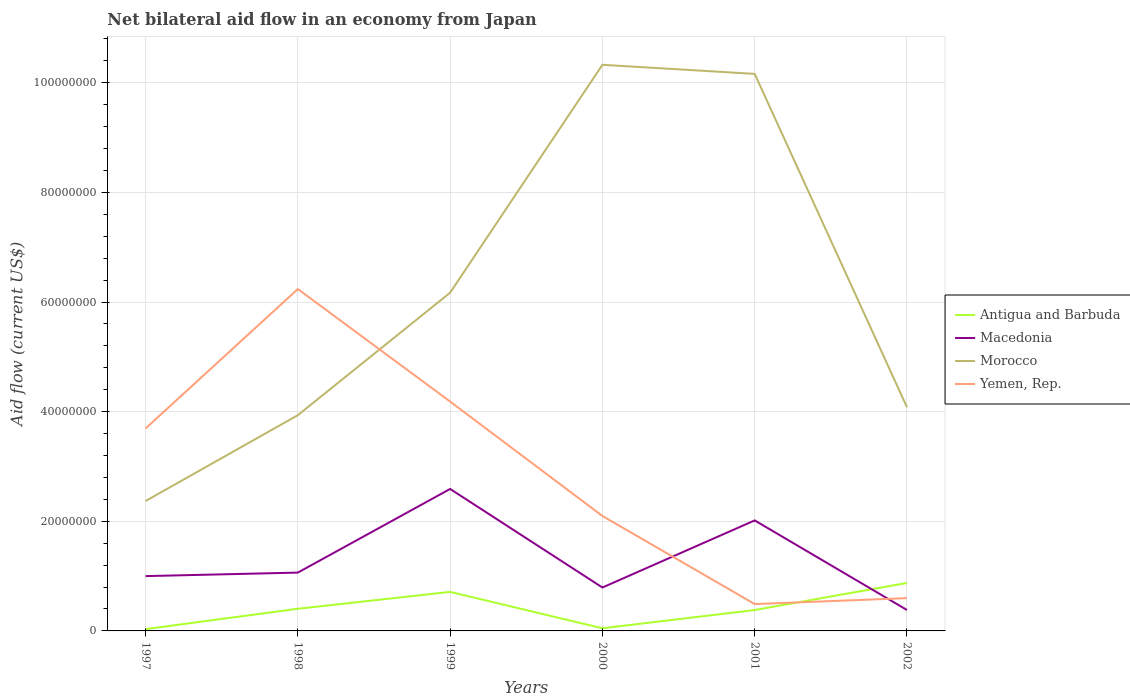Across all years, what is the maximum net bilateral aid flow in Antigua and Barbuda?
Offer a terse response. 3.30e+05. In which year was the net bilateral aid flow in Macedonia maximum?
Your answer should be very brief. 2002. What is the total net bilateral aid flow in Antigua and Barbuda in the graph?
Offer a terse response. -4.94e+06. What is the difference between the highest and the second highest net bilateral aid flow in Macedonia?
Your answer should be very brief. 2.21e+07. What is the difference between the highest and the lowest net bilateral aid flow in Yemen, Rep.?
Give a very brief answer. 3. Is the net bilateral aid flow in Macedonia strictly greater than the net bilateral aid flow in Antigua and Barbuda over the years?
Your answer should be very brief. No. How many lines are there?
Your response must be concise. 4. What is the difference between two consecutive major ticks on the Y-axis?
Offer a very short reply. 2.00e+07. Are the values on the major ticks of Y-axis written in scientific E-notation?
Offer a terse response. No. Does the graph contain grids?
Give a very brief answer. Yes. What is the title of the graph?
Your response must be concise. Net bilateral aid flow in an economy from Japan. What is the label or title of the Y-axis?
Offer a very short reply. Aid flow (current US$). What is the Aid flow (current US$) in Antigua and Barbuda in 1997?
Provide a succinct answer. 3.30e+05. What is the Aid flow (current US$) of Macedonia in 1997?
Keep it short and to the point. 1.00e+07. What is the Aid flow (current US$) in Morocco in 1997?
Make the answer very short. 2.37e+07. What is the Aid flow (current US$) in Yemen, Rep. in 1997?
Offer a very short reply. 3.69e+07. What is the Aid flow (current US$) of Antigua and Barbuda in 1998?
Provide a short and direct response. 4.04e+06. What is the Aid flow (current US$) in Macedonia in 1998?
Keep it short and to the point. 1.06e+07. What is the Aid flow (current US$) in Morocco in 1998?
Offer a very short reply. 3.94e+07. What is the Aid flow (current US$) in Yemen, Rep. in 1998?
Offer a very short reply. 6.24e+07. What is the Aid flow (current US$) of Antigua and Barbuda in 1999?
Provide a short and direct response. 7.12e+06. What is the Aid flow (current US$) of Macedonia in 1999?
Your response must be concise. 2.59e+07. What is the Aid flow (current US$) of Morocco in 1999?
Offer a very short reply. 6.17e+07. What is the Aid flow (current US$) of Yemen, Rep. in 1999?
Make the answer very short. 4.18e+07. What is the Aid flow (current US$) in Macedonia in 2000?
Make the answer very short. 7.92e+06. What is the Aid flow (current US$) of Morocco in 2000?
Make the answer very short. 1.03e+08. What is the Aid flow (current US$) of Yemen, Rep. in 2000?
Offer a terse response. 2.10e+07. What is the Aid flow (current US$) of Antigua and Barbuda in 2001?
Give a very brief answer. 3.81e+06. What is the Aid flow (current US$) of Macedonia in 2001?
Ensure brevity in your answer.  2.02e+07. What is the Aid flow (current US$) of Morocco in 2001?
Keep it short and to the point. 1.02e+08. What is the Aid flow (current US$) of Yemen, Rep. in 2001?
Ensure brevity in your answer.  4.90e+06. What is the Aid flow (current US$) of Antigua and Barbuda in 2002?
Make the answer very short. 8.75e+06. What is the Aid flow (current US$) in Macedonia in 2002?
Provide a short and direct response. 3.82e+06. What is the Aid flow (current US$) in Morocco in 2002?
Provide a succinct answer. 4.08e+07. What is the Aid flow (current US$) of Yemen, Rep. in 2002?
Offer a very short reply. 5.98e+06. Across all years, what is the maximum Aid flow (current US$) in Antigua and Barbuda?
Your answer should be compact. 8.75e+06. Across all years, what is the maximum Aid flow (current US$) in Macedonia?
Give a very brief answer. 2.59e+07. Across all years, what is the maximum Aid flow (current US$) in Morocco?
Keep it short and to the point. 1.03e+08. Across all years, what is the maximum Aid flow (current US$) of Yemen, Rep.?
Your answer should be compact. 6.24e+07. Across all years, what is the minimum Aid flow (current US$) in Antigua and Barbuda?
Your response must be concise. 3.30e+05. Across all years, what is the minimum Aid flow (current US$) in Macedonia?
Provide a succinct answer. 3.82e+06. Across all years, what is the minimum Aid flow (current US$) of Morocco?
Keep it short and to the point. 2.37e+07. Across all years, what is the minimum Aid flow (current US$) in Yemen, Rep.?
Keep it short and to the point. 4.90e+06. What is the total Aid flow (current US$) of Antigua and Barbuda in the graph?
Ensure brevity in your answer.  2.45e+07. What is the total Aid flow (current US$) of Macedonia in the graph?
Keep it short and to the point. 7.84e+07. What is the total Aid flow (current US$) in Morocco in the graph?
Your answer should be compact. 3.70e+08. What is the total Aid flow (current US$) in Yemen, Rep. in the graph?
Provide a succinct answer. 1.73e+08. What is the difference between the Aid flow (current US$) in Antigua and Barbuda in 1997 and that in 1998?
Your answer should be compact. -3.71e+06. What is the difference between the Aid flow (current US$) in Macedonia in 1997 and that in 1998?
Your answer should be compact. -6.40e+05. What is the difference between the Aid flow (current US$) of Morocco in 1997 and that in 1998?
Your answer should be very brief. -1.57e+07. What is the difference between the Aid flow (current US$) in Yemen, Rep. in 1997 and that in 1998?
Keep it short and to the point. -2.54e+07. What is the difference between the Aid flow (current US$) of Antigua and Barbuda in 1997 and that in 1999?
Provide a succinct answer. -6.79e+06. What is the difference between the Aid flow (current US$) of Macedonia in 1997 and that in 1999?
Give a very brief answer. -1.59e+07. What is the difference between the Aid flow (current US$) in Morocco in 1997 and that in 1999?
Offer a very short reply. -3.80e+07. What is the difference between the Aid flow (current US$) in Yemen, Rep. in 1997 and that in 1999?
Make the answer very short. -4.91e+06. What is the difference between the Aid flow (current US$) in Macedonia in 1997 and that in 2000?
Your answer should be compact. 2.08e+06. What is the difference between the Aid flow (current US$) of Morocco in 1997 and that in 2000?
Make the answer very short. -7.96e+07. What is the difference between the Aid flow (current US$) in Yemen, Rep. in 1997 and that in 2000?
Provide a succinct answer. 1.60e+07. What is the difference between the Aid flow (current US$) of Antigua and Barbuda in 1997 and that in 2001?
Ensure brevity in your answer.  -3.48e+06. What is the difference between the Aid flow (current US$) of Macedonia in 1997 and that in 2001?
Your answer should be very brief. -1.02e+07. What is the difference between the Aid flow (current US$) of Morocco in 1997 and that in 2001?
Your answer should be compact. -7.79e+07. What is the difference between the Aid flow (current US$) in Yemen, Rep. in 1997 and that in 2001?
Give a very brief answer. 3.20e+07. What is the difference between the Aid flow (current US$) of Antigua and Barbuda in 1997 and that in 2002?
Ensure brevity in your answer.  -8.42e+06. What is the difference between the Aid flow (current US$) in Macedonia in 1997 and that in 2002?
Offer a very short reply. 6.18e+06. What is the difference between the Aid flow (current US$) in Morocco in 1997 and that in 2002?
Offer a very short reply. -1.71e+07. What is the difference between the Aid flow (current US$) of Yemen, Rep. in 1997 and that in 2002?
Ensure brevity in your answer.  3.10e+07. What is the difference between the Aid flow (current US$) in Antigua and Barbuda in 1998 and that in 1999?
Your answer should be compact. -3.08e+06. What is the difference between the Aid flow (current US$) of Macedonia in 1998 and that in 1999?
Give a very brief answer. -1.53e+07. What is the difference between the Aid flow (current US$) of Morocco in 1998 and that in 1999?
Give a very brief answer. -2.24e+07. What is the difference between the Aid flow (current US$) in Yemen, Rep. in 1998 and that in 1999?
Offer a very short reply. 2.05e+07. What is the difference between the Aid flow (current US$) in Antigua and Barbuda in 1998 and that in 2000?
Provide a short and direct response. 3.56e+06. What is the difference between the Aid flow (current US$) of Macedonia in 1998 and that in 2000?
Your answer should be compact. 2.72e+06. What is the difference between the Aid flow (current US$) in Morocco in 1998 and that in 2000?
Your answer should be very brief. -6.39e+07. What is the difference between the Aid flow (current US$) in Yemen, Rep. in 1998 and that in 2000?
Your answer should be very brief. 4.14e+07. What is the difference between the Aid flow (current US$) of Antigua and Barbuda in 1998 and that in 2001?
Provide a succinct answer. 2.30e+05. What is the difference between the Aid flow (current US$) in Macedonia in 1998 and that in 2001?
Keep it short and to the point. -9.52e+06. What is the difference between the Aid flow (current US$) of Morocco in 1998 and that in 2001?
Provide a short and direct response. -6.23e+07. What is the difference between the Aid flow (current US$) in Yemen, Rep. in 1998 and that in 2001?
Your response must be concise. 5.75e+07. What is the difference between the Aid flow (current US$) of Antigua and Barbuda in 1998 and that in 2002?
Offer a terse response. -4.71e+06. What is the difference between the Aid flow (current US$) of Macedonia in 1998 and that in 2002?
Your answer should be very brief. 6.82e+06. What is the difference between the Aid flow (current US$) of Morocco in 1998 and that in 2002?
Give a very brief answer. -1.44e+06. What is the difference between the Aid flow (current US$) of Yemen, Rep. in 1998 and that in 2002?
Give a very brief answer. 5.64e+07. What is the difference between the Aid flow (current US$) of Antigua and Barbuda in 1999 and that in 2000?
Your response must be concise. 6.64e+06. What is the difference between the Aid flow (current US$) in Macedonia in 1999 and that in 2000?
Give a very brief answer. 1.80e+07. What is the difference between the Aid flow (current US$) in Morocco in 1999 and that in 2000?
Offer a very short reply. -4.16e+07. What is the difference between the Aid flow (current US$) in Yemen, Rep. in 1999 and that in 2000?
Your response must be concise. 2.09e+07. What is the difference between the Aid flow (current US$) of Antigua and Barbuda in 1999 and that in 2001?
Your answer should be very brief. 3.31e+06. What is the difference between the Aid flow (current US$) of Macedonia in 1999 and that in 2001?
Make the answer very short. 5.74e+06. What is the difference between the Aid flow (current US$) in Morocco in 1999 and that in 2001?
Make the answer very short. -3.99e+07. What is the difference between the Aid flow (current US$) in Yemen, Rep. in 1999 and that in 2001?
Your answer should be compact. 3.69e+07. What is the difference between the Aid flow (current US$) of Antigua and Barbuda in 1999 and that in 2002?
Your answer should be compact. -1.63e+06. What is the difference between the Aid flow (current US$) in Macedonia in 1999 and that in 2002?
Provide a succinct answer. 2.21e+07. What is the difference between the Aid flow (current US$) of Morocco in 1999 and that in 2002?
Keep it short and to the point. 2.09e+07. What is the difference between the Aid flow (current US$) in Yemen, Rep. in 1999 and that in 2002?
Make the answer very short. 3.59e+07. What is the difference between the Aid flow (current US$) in Antigua and Barbuda in 2000 and that in 2001?
Keep it short and to the point. -3.33e+06. What is the difference between the Aid flow (current US$) in Macedonia in 2000 and that in 2001?
Offer a very short reply. -1.22e+07. What is the difference between the Aid flow (current US$) of Morocco in 2000 and that in 2001?
Offer a very short reply. 1.66e+06. What is the difference between the Aid flow (current US$) of Yemen, Rep. in 2000 and that in 2001?
Offer a terse response. 1.61e+07. What is the difference between the Aid flow (current US$) of Antigua and Barbuda in 2000 and that in 2002?
Give a very brief answer. -8.27e+06. What is the difference between the Aid flow (current US$) of Macedonia in 2000 and that in 2002?
Your answer should be very brief. 4.10e+06. What is the difference between the Aid flow (current US$) of Morocco in 2000 and that in 2002?
Offer a very short reply. 6.25e+07. What is the difference between the Aid flow (current US$) of Yemen, Rep. in 2000 and that in 2002?
Keep it short and to the point. 1.50e+07. What is the difference between the Aid flow (current US$) in Antigua and Barbuda in 2001 and that in 2002?
Offer a terse response. -4.94e+06. What is the difference between the Aid flow (current US$) in Macedonia in 2001 and that in 2002?
Give a very brief answer. 1.63e+07. What is the difference between the Aid flow (current US$) of Morocco in 2001 and that in 2002?
Give a very brief answer. 6.08e+07. What is the difference between the Aid flow (current US$) in Yemen, Rep. in 2001 and that in 2002?
Offer a very short reply. -1.08e+06. What is the difference between the Aid flow (current US$) in Antigua and Barbuda in 1997 and the Aid flow (current US$) in Macedonia in 1998?
Offer a terse response. -1.03e+07. What is the difference between the Aid flow (current US$) in Antigua and Barbuda in 1997 and the Aid flow (current US$) in Morocco in 1998?
Give a very brief answer. -3.90e+07. What is the difference between the Aid flow (current US$) in Antigua and Barbuda in 1997 and the Aid flow (current US$) in Yemen, Rep. in 1998?
Make the answer very short. -6.20e+07. What is the difference between the Aid flow (current US$) of Macedonia in 1997 and the Aid flow (current US$) of Morocco in 1998?
Offer a very short reply. -2.94e+07. What is the difference between the Aid flow (current US$) in Macedonia in 1997 and the Aid flow (current US$) in Yemen, Rep. in 1998?
Make the answer very short. -5.24e+07. What is the difference between the Aid flow (current US$) in Morocco in 1997 and the Aid flow (current US$) in Yemen, Rep. in 1998?
Keep it short and to the point. -3.87e+07. What is the difference between the Aid flow (current US$) of Antigua and Barbuda in 1997 and the Aid flow (current US$) of Macedonia in 1999?
Offer a very short reply. -2.56e+07. What is the difference between the Aid flow (current US$) in Antigua and Barbuda in 1997 and the Aid flow (current US$) in Morocco in 1999?
Give a very brief answer. -6.14e+07. What is the difference between the Aid flow (current US$) of Antigua and Barbuda in 1997 and the Aid flow (current US$) of Yemen, Rep. in 1999?
Give a very brief answer. -4.15e+07. What is the difference between the Aid flow (current US$) of Macedonia in 1997 and the Aid flow (current US$) of Morocco in 1999?
Provide a succinct answer. -5.17e+07. What is the difference between the Aid flow (current US$) of Macedonia in 1997 and the Aid flow (current US$) of Yemen, Rep. in 1999?
Your response must be concise. -3.18e+07. What is the difference between the Aid flow (current US$) of Morocco in 1997 and the Aid flow (current US$) of Yemen, Rep. in 1999?
Ensure brevity in your answer.  -1.81e+07. What is the difference between the Aid flow (current US$) in Antigua and Barbuda in 1997 and the Aid flow (current US$) in Macedonia in 2000?
Give a very brief answer. -7.59e+06. What is the difference between the Aid flow (current US$) in Antigua and Barbuda in 1997 and the Aid flow (current US$) in Morocco in 2000?
Provide a succinct answer. -1.03e+08. What is the difference between the Aid flow (current US$) in Antigua and Barbuda in 1997 and the Aid flow (current US$) in Yemen, Rep. in 2000?
Your response must be concise. -2.06e+07. What is the difference between the Aid flow (current US$) of Macedonia in 1997 and the Aid flow (current US$) of Morocco in 2000?
Offer a terse response. -9.33e+07. What is the difference between the Aid flow (current US$) of Macedonia in 1997 and the Aid flow (current US$) of Yemen, Rep. in 2000?
Make the answer very short. -1.10e+07. What is the difference between the Aid flow (current US$) of Morocco in 1997 and the Aid flow (current US$) of Yemen, Rep. in 2000?
Offer a terse response. 2.73e+06. What is the difference between the Aid flow (current US$) of Antigua and Barbuda in 1997 and the Aid flow (current US$) of Macedonia in 2001?
Provide a short and direct response. -1.98e+07. What is the difference between the Aid flow (current US$) of Antigua and Barbuda in 1997 and the Aid flow (current US$) of Morocco in 2001?
Give a very brief answer. -1.01e+08. What is the difference between the Aid flow (current US$) of Antigua and Barbuda in 1997 and the Aid flow (current US$) of Yemen, Rep. in 2001?
Your response must be concise. -4.57e+06. What is the difference between the Aid flow (current US$) in Macedonia in 1997 and the Aid flow (current US$) in Morocco in 2001?
Offer a very short reply. -9.16e+07. What is the difference between the Aid flow (current US$) in Macedonia in 1997 and the Aid flow (current US$) in Yemen, Rep. in 2001?
Give a very brief answer. 5.10e+06. What is the difference between the Aid flow (current US$) of Morocco in 1997 and the Aid flow (current US$) of Yemen, Rep. in 2001?
Your answer should be very brief. 1.88e+07. What is the difference between the Aid flow (current US$) in Antigua and Barbuda in 1997 and the Aid flow (current US$) in Macedonia in 2002?
Ensure brevity in your answer.  -3.49e+06. What is the difference between the Aid flow (current US$) of Antigua and Barbuda in 1997 and the Aid flow (current US$) of Morocco in 2002?
Your response must be concise. -4.05e+07. What is the difference between the Aid flow (current US$) of Antigua and Barbuda in 1997 and the Aid flow (current US$) of Yemen, Rep. in 2002?
Make the answer very short. -5.65e+06. What is the difference between the Aid flow (current US$) of Macedonia in 1997 and the Aid flow (current US$) of Morocco in 2002?
Ensure brevity in your answer.  -3.08e+07. What is the difference between the Aid flow (current US$) of Macedonia in 1997 and the Aid flow (current US$) of Yemen, Rep. in 2002?
Your answer should be very brief. 4.02e+06. What is the difference between the Aid flow (current US$) in Morocco in 1997 and the Aid flow (current US$) in Yemen, Rep. in 2002?
Ensure brevity in your answer.  1.77e+07. What is the difference between the Aid flow (current US$) in Antigua and Barbuda in 1998 and the Aid flow (current US$) in Macedonia in 1999?
Your answer should be very brief. -2.19e+07. What is the difference between the Aid flow (current US$) of Antigua and Barbuda in 1998 and the Aid flow (current US$) of Morocco in 1999?
Offer a very short reply. -5.77e+07. What is the difference between the Aid flow (current US$) of Antigua and Barbuda in 1998 and the Aid flow (current US$) of Yemen, Rep. in 1999?
Your answer should be very brief. -3.78e+07. What is the difference between the Aid flow (current US$) in Macedonia in 1998 and the Aid flow (current US$) in Morocco in 1999?
Give a very brief answer. -5.11e+07. What is the difference between the Aid flow (current US$) in Macedonia in 1998 and the Aid flow (current US$) in Yemen, Rep. in 1999?
Offer a terse response. -3.12e+07. What is the difference between the Aid flow (current US$) of Morocco in 1998 and the Aid flow (current US$) of Yemen, Rep. in 1999?
Keep it short and to the point. -2.48e+06. What is the difference between the Aid flow (current US$) in Antigua and Barbuda in 1998 and the Aid flow (current US$) in Macedonia in 2000?
Offer a very short reply. -3.88e+06. What is the difference between the Aid flow (current US$) of Antigua and Barbuda in 1998 and the Aid flow (current US$) of Morocco in 2000?
Your response must be concise. -9.92e+07. What is the difference between the Aid flow (current US$) of Antigua and Barbuda in 1998 and the Aid flow (current US$) of Yemen, Rep. in 2000?
Your answer should be compact. -1.69e+07. What is the difference between the Aid flow (current US$) in Macedonia in 1998 and the Aid flow (current US$) in Morocco in 2000?
Ensure brevity in your answer.  -9.26e+07. What is the difference between the Aid flow (current US$) in Macedonia in 1998 and the Aid flow (current US$) in Yemen, Rep. in 2000?
Provide a short and direct response. -1.03e+07. What is the difference between the Aid flow (current US$) of Morocco in 1998 and the Aid flow (current US$) of Yemen, Rep. in 2000?
Ensure brevity in your answer.  1.84e+07. What is the difference between the Aid flow (current US$) of Antigua and Barbuda in 1998 and the Aid flow (current US$) of Macedonia in 2001?
Offer a very short reply. -1.61e+07. What is the difference between the Aid flow (current US$) of Antigua and Barbuda in 1998 and the Aid flow (current US$) of Morocco in 2001?
Give a very brief answer. -9.76e+07. What is the difference between the Aid flow (current US$) of Antigua and Barbuda in 1998 and the Aid flow (current US$) of Yemen, Rep. in 2001?
Make the answer very short. -8.60e+05. What is the difference between the Aid flow (current US$) of Macedonia in 1998 and the Aid flow (current US$) of Morocco in 2001?
Ensure brevity in your answer.  -9.10e+07. What is the difference between the Aid flow (current US$) in Macedonia in 1998 and the Aid flow (current US$) in Yemen, Rep. in 2001?
Provide a succinct answer. 5.74e+06. What is the difference between the Aid flow (current US$) in Morocco in 1998 and the Aid flow (current US$) in Yemen, Rep. in 2001?
Offer a very short reply. 3.45e+07. What is the difference between the Aid flow (current US$) of Antigua and Barbuda in 1998 and the Aid flow (current US$) of Macedonia in 2002?
Make the answer very short. 2.20e+05. What is the difference between the Aid flow (current US$) of Antigua and Barbuda in 1998 and the Aid flow (current US$) of Morocco in 2002?
Give a very brief answer. -3.68e+07. What is the difference between the Aid flow (current US$) in Antigua and Barbuda in 1998 and the Aid flow (current US$) in Yemen, Rep. in 2002?
Your answer should be compact. -1.94e+06. What is the difference between the Aid flow (current US$) in Macedonia in 1998 and the Aid flow (current US$) in Morocco in 2002?
Your response must be concise. -3.02e+07. What is the difference between the Aid flow (current US$) in Macedonia in 1998 and the Aid flow (current US$) in Yemen, Rep. in 2002?
Keep it short and to the point. 4.66e+06. What is the difference between the Aid flow (current US$) in Morocco in 1998 and the Aid flow (current US$) in Yemen, Rep. in 2002?
Your answer should be compact. 3.34e+07. What is the difference between the Aid flow (current US$) of Antigua and Barbuda in 1999 and the Aid flow (current US$) of Macedonia in 2000?
Provide a short and direct response. -8.00e+05. What is the difference between the Aid flow (current US$) in Antigua and Barbuda in 1999 and the Aid flow (current US$) in Morocco in 2000?
Keep it short and to the point. -9.62e+07. What is the difference between the Aid flow (current US$) in Antigua and Barbuda in 1999 and the Aid flow (current US$) in Yemen, Rep. in 2000?
Your response must be concise. -1.38e+07. What is the difference between the Aid flow (current US$) of Macedonia in 1999 and the Aid flow (current US$) of Morocco in 2000?
Make the answer very short. -7.74e+07. What is the difference between the Aid flow (current US$) in Macedonia in 1999 and the Aid flow (current US$) in Yemen, Rep. in 2000?
Your answer should be compact. 4.93e+06. What is the difference between the Aid flow (current US$) in Morocco in 1999 and the Aid flow (current US$) in Yemen, Rep. in 2000?
Your response must be concise. 4.07e+07. What is the difference between the Aid flow (current US$) in Antigua and Barbuda in 1999 and the Aid flow (current US$) in Macedonia in 2001?
Offer a very short reply. -1.30e+07. What is the difference between the Aid flow (current US$) in Antigua and Barbuda in 1999 and the Aid flow (current US$) in Morocco in 2001?
Ensure brevity in your answer.  -9.45e+07. What is the difference between the Aid flow (current US$) of Antigua and Barbuda in 1999 and the Aid flow (current US$) of Yemen, Rep. in 2001?
Your response must be concise. 2.22e+06. What is the difference between the Aid flow (current US$) in Macedonia in 1999 and the Aid flow (current US$) in Morocco in 2001?
Keep it short and to the point. -7.57e+07. What is the difference between the Aid flow (current US$) in Macedonia in 1999 and the Aid flow (current US$) in Yemen, Rep. in 2001?
Keep it short and to the point. 2.10e+07. What is the difference between the Aid flow (current US$) in Morocco in 1999 and the Aid flow (current US$) in Yemen, Rep. in 2001?
Ensure brevity in your answer.  5.68e+07. What is the difference between the Aid flow (current US$) in Antigua and Barbuda in 1999 and the Aid flow (current US$) in Macedonia in 2002?
Provide a succinct answer. 3.30e+06. What is the difference between the Aid flow (current US$) of Antigua and Barbuda in 1999 and the Aid flow (current US$) of Morocco in 2002?
Provide a short and direct response. -3.37e+07. What is the difference between the Aid flow (current US$) of Antigua and Barbuda in 1999 and the Aid flow (current US$) of Yemen, Rep. in 2002?
Your answer should be compact. 1.14e+06. What is the difference between the Aid flow (current US$) of Macedonia in 1999 and the Aid flow (current US$) of Morocco in 2002?
Keep it short and to the point. -1.49e+07. What is the difference between the Aid flow (current US$) in Macedonia in 1999 and the Aid flow (current US$) in Yemen, Rep. in 2002?
Your answer should be very brief. 1.99e+07. What is the difference between the Aid flow (current US$) of Morocco in 1999 and the Aid flow (current US$) of Yemen, Rep. in 2002?
Provide a short and direct response. 5.57e+07. What is the difference between the Aid flow (current US$) in Antigua and Barbuda in 2000 and the Aid flow (current US$) in Macedonia in 2001?
Offer a very short reply. -1.97e+07. What is the difference between the Aid flow (current US$) of Antigua and Barbuda in 2000 and the Aid flow (current US$) of Morocco in 2001?
Provide a succinct answer. -1.01e+08. What is the difference between the Aid flow (current US$) in Antigua and Barbuda in 2000 and the Aid flow (current US$) in Yemen, Rep. in 2001?
Make the answer very short. -4.42e+06. What is the difference between the Aid flow (current US$) of Macedonia in 2000 and the Aid flow (current US$) of Morocco in 2001?
Offer a terse response. -9.37e+07. What is the difference between the Aid flow (current US$) in Macedonia in 2000 and the Aid flow (current US$) in Yemen, Rep. in 2001?
Your response must be concise. 3.02e+06. What is the difference between the Aid flow (current US$) in Morocco in 2000 and the Aid flow (current US$) in Yemen, Rep. in 2001?
Your answer should be compact. 9.84e+07. What is the difference between the Aid flow (current US$) of Antigua and Barbuda in 2000 and the Aid flow (current US$) of Macedonia in 2002?
Provide a short and direct response. -3.34e+06. What is the difference between the Aid flow (current US$) of Antigua and Barbuda in 2000 and the Aid flow (current US$) of Morocco in 2002?
Provide a succinct answer. -4.03e+07. What is the difference between the Aid flow (current US$) in Antigua and Barbuda in 2000 and the Aid flow (current US$) in Yemen, Rep. in 2002?
Your answer should be very brief. -5.50e+06. What is the difference between the Aid flow (current US$) in Macedonia in 2000 and the Aid flow (current US$) in Morocco in 2002?
Give a very brief answer. -3.29e+07. What is the difference between the Aid flow (current US$) in Macedonia in 2000 and the Aid flow (current US$) in Yemen, Rep. in 2002?
Offer a very short reply. 1.94e+06. What is the difference between the Aid flow (current US$) in Morocco in 2000 and the Aid flow (current US$) in Yemen, Rep. in 2002?
Offer a very short reply. 9.73e+07. What is the difference between the Aid flow (current US$) in Antigua and Barbuda in 2001 and the Aid flow (current US$) in Macedonia in 2002?
Provide a succinct answer. -10000. What is the difference between the Aid flow (current US$) in Antigua and Barbuda in 2001 and the Aid flow (current US$) in Morocco in 2002?
Make the answer very short. -3.70e+07. What is the difference between the Aid flow (current US$) in Antigua and Barbuda in 2001 and the Aid flow (current US$) in Yemen, Rep. in 2002?
Your answer should be compact. -2.17e+06. What is the difference between the Aid flow (current US$) of Macedonia in 2001 and the Aid flow (current US$) of Morocco in 2002?
Provide a short and direct response. -2.06e+07. What is the difference between the Aid flow (current US$) of Macedonia in 2001 and the Aid flow (current US$) of Yemen, Rep. in 2002?
Your answer should be compact. 1.42e+07. What is the difference between the Aid flow (current US$) of Morocco in 2001 and the Aid flow (current US$) of Yemen, Rep. in 2002?
Your answer should be very brief. 9.56e+07. What is the average Aid flow (current US$) of Antigua and Barbuda per year?
Provide a short and direct response. 4.09e+06. What is the average Aid flow (current US$) of Macedonia per year?
Ensure brevity in your answer.  1.31e+07. What is the average Aid flow (current US$) in Morocco per year?
Offer a very short reply. 6.17e+07. What is the average Aid flow (current US$) of Yemen, Rep. per year?
Ensure brevity in your answer.  2.88e+07. In the year 1997, what is the difference between the Aid flow (current US$) in Antigua and Barbuda and Aid flow (current US$) in Macedonia?
Make the answer very short. -9.67e+06. In the year 1997, what is the difference between the Aid flow (current US$) in Antigua and Barbuda and Aid flow (current US$) in Morocco?
Give a very brief answer. -2.34e+07. In the year 1997, what is the difference between the Aid flow (current US$) of Antigua and Barbuda and Aid flow (current US$) of Yemen, Rep.?
Ensure brevity in your answer.  -3.66e+07. In the year 1997, what is the difference between the Aid flow (current US$) in Macedonia and Aid flow (current US$) in Morocco?
Provide a short and direct response. -1.37e+07. In the year 1997, what is the difference between the Aid flow (current US$) of Macedonia and Aid flow (current US$) of Yemen, Rep.?
Your answer should be compact. -2.69e+07. In the year 1997, what is the difference between the Aid flow (current US$) in Morocco and Aid flow (current US$) in Yemen, Rep.?
Keep it short and to the point. -1.32e+07. In the year 1998, what is the difference between the Aid flow (current US$) in Antigua and Barbuda and Aid flow (current US$) in Macedonia?
Provide a short and direct response. -6.60e+06. In the year 1998, what is the difference between the Aid flow (current US$) of Antigua and Barbuda and Aid flow (current US$) of Morocco?
Your answer should be very brief. -3.53e+07. In the year 1998, what is the difference between the Aid flow (current US$) of Antigua and Barbuda and Aid flow (current US$) of Yemen, Rep.?
Offer a terse response. -5.83e+07. In the year 1998, what is the difference between the Aid flow (current US$) of Macedonia and Aid flow (current US$) of Morocco?
Provide a short and direct response. -2.87e+07. In the year 1998, what is the difference between the Aid flow (current US$) in Macedonia and Aid flow (current US$) in Yemen, Rep.?
Offer a terse response. -5.17e+07. In the year 1998, what is the difference between the Aid flow (current US$) of Morocco and Aid flow (current US$) of Yemen, Rep.?
Your answer should be very brief. -2.30e+07. In the year 1999, what is the difference between the Aid flow (current US$) in Antigua and Barbuda and Aid flow (current US$) in Macedonia?
Provide a short and direct response. -1.88e+07. In the year 1999, what is the difference between the Aid flow (current US$) of Antigua and Barbuda and Aid flow (current US$) of Morocco?
Make the answer very short. -5.46e+07. In the year 1999, what is the difference between the Aid flow (current US$) of Antigua and Barbuda and Aid flow (current US$) of Yemen, Rep.?
Make the answer very short. -3.47e+07. In the year 1999, what is the difference between the Aid flow (current US$) in Macedonia and Aid flow (current US$) in Morocco?
Your answer should be very brief. -3.58e+07. In the year 1999, what is the difference between the Aid flow (current US$) of Macedonia and Aid flow (current US$) of Yemen, Rep.?
Offer a terse response. -1.59e+07. In the year 1999, what is the difference between the Aid flow (current US$) of Morocco and Aid flow (current US$) of Yemen, Rep.?
Ensure brevity in your answer.  1.99e+07. In the year 2000, what is the difference between the Aid flow (current US$) of Antigua and Barbuda and Aid flow (current US$) of Macedonia?
Ensure brevity in your answer.  -7.44e+06. In the year 2000, what is the difference between the Aid flow (current US$) in Antigua and Barbuda and Aid flow (current US$) in Morocco?
Offer a terse response. -1.03e+08. In the year 2000, what is the difference between the Aid flow (current US$) in Antigua and Barbuda and Aid flow (current US$) in Yemen, Rep.?
Offer a terse response. -2.05e+07. In the year 2000, what is the difference between the Aid flow (current US$) in Macedonia and Aid flow (current US$) in Morocco?
Make the answer very short. -9.54e+07. In the year 2000, what is the difference between the Aid flow (current US$) of Macedonia and Aid flow (current US$) of Yemen, Rep.?
Provide a short and direct response. -1.30e+07. In the year 2000, what is the difference between the Aid flow (current US$) of Morocco and Aid flow (current US$) of Yemen, Rep.?
Ensure brevity in your answer.  8.23e+07. In the year 2001, what is the difference between the Aid flow (current US$) of Antigua and Barbuda and Aid flow (current US$) of Macedonia?
Provide a succinct answer. -1.64e+07. In the year 2001, what is the difference between the Aid flow (current US$) of Antigua and Barbuda and Aid flow (current US$) of Morocco?
Offer a terse response. -9.78e+07. In the year 2001, what is the difference between the Aid flow (current US$) in Antigua and Barbuda and Aid flow (current US$) in Yemen, Rep.?
Provide a short and direct response. -1.09e+06. In the year 2001, what is the difference between the Aid flow (current US$) in Macedonia and Aid flow (current US$) in Morocco?
Your response must be concise. -8.15e+07. In the year 2001, what is the difference between the Aid flow (current US$) of Macedonia and Aid flow (current US$) of Yemen, Rep.?
Ensure brevity in your answer.  1.53e+07. In the year 2001, what is the difference between the Aid flow (current US$) of Morocco and Aid flow (current US$) of Yemen, Rep.?
Offer a very short reply. 9.67e+07. In the year 2002, what is the difference between the Aid flow (current US$) in Antigua and Barbuda and Aid flow (current US$) in Macedonia?
Your response must be concise. 4.93e+06. In the year 2002, what is the difference between the Aid flow (current US$) in Antigua and Barbuda and Aid flow (current US$) in Morocco?
Give a very brief answer. -3.20e+07. In the year 2002, what is the difference between the Aid flow (current US$) of Antigua and Barbuda and Aid flow (current US$) of Yemen, Rep.?
Keep it short and to the point. 2.77e+06. In the year 2002, what is the difference between the Aid flow (current US$) of Macedonia and Aid flow (current US$) of Morocco?
Your answer should be compact. -3.70e+07. In the year 2002, what is the difference between the Aid flow (current US$) of Macedonia and Aid flow (current US$) of Yemen, Rep.?
Your response must be concise. -2.16e+06. In the year 2002, what is the difference between the Aid flow (current US$) of Morocco and Aid flow (current US$) of Yemen, Rep.?
Your answer should be compact. 3.48e+07. What is the ratio of the Aid flow (current US$) in Antigua and Barbuda in 1997 to that in 1998?
Your response must be concise. 0.08. What is the ratio of the Aid flow (current US$) of Macedonia in 1997 to that in 1998?
Offer a very short reply. 0.94. What is the ratio of the Aid flow (current US$) in Morocco in 1997 to that in 1998?
Provide a succinct answer. 0.6. What is the ratio of the Aid flow (current US$) in Yemen, Rep. in 1997 to that in 1998?
Offer a terse response. 0.59. What is the ratio of the Aid flow (current US$) in Antigua and Barbuda in 1997 to that in 1999?
Provide a short and direct response. 0.05. What is the ratio of the Aid flow (current US$) of Macedonia in 1997 to that in 1999?
Offer a very short reply. 0.39. What is the ratio of the Aid flow (current US$) of Morocco in 1997 to that in 1999?
Keep it short and to the point. 0.38. What is the ratio of the Aid flow (current US$) in Yemen, Rep. in 1997 to that in 1999?
Provide a succinct answer. 0.88. What is the ratio of the Aid flow (current US$) in Antigua and Barbuda in 1997 to that in 2000?
Provide a succinct answer. 0.69. What is the ratio of the Aid flow (current US$) of Macedonia in 1997 to that in 2000?
Provide a short and direct response. 1.26. What is the ratio of the Aid flow (current US$) in Morocco in 1997 to that in 2000?
Provide a succinct answer. 0.23. What is the ratio of the Aid flow (current US$) of Yemen, Rep. in 1997 to that in 2000?
Your response must be concise. 1.76. What is the ratio of the Aid flow (current US$) of Antigua and Barbuda in 1997 to that in 2001?
Your answer should be compact. 0.09. What is the ratio of the Aid flow (current US$) in Macedonia in 1997 to that in 2001?
Offer a terse response. 0.5. What is the ratio of the Aid flow (current US$) in Morocco in 1997 to that in 2001?
Ensure brevity in your answer.  0.23. What is the ratio of the Aid flow (current US$) in Yemen, Rep. in 1997 to that in 2001?
Make the answer very short. 7.54. What is the ratio of the Aid flow (current US$) of Antigua and Barbuda in 1997 to that in 2002?
Your answer should be very brief. 0.04. What is the ratio of the Aid flow (current US$) of Macedonia in 1997 to that in 2002?
Offer a very short reply. 2.62. What is the ratio of the Aid flow (current US$) of Morocco in 1997 to that in 2002?
Your response must be concise. 0.58. What is the ratio of the Aid flow (current US$) of Yemen, Rep. in 1997 to that in 2002?
Keep it short and to the point. 6.18. What is the ratio of the Aid flow (current US$) in Antigua and Barbuda in 1998 to that in 1999?
Ensure brevity in your answer.  0.57. What is the ratio of the Aid flow (current US$) in Macedonia in 1998 to that in 1999?
Offer a terse response. 0.41. What is the ratio of the Aid flow (current US$) in Morocco in 1998 to that in 1999?
Provide a short and direct response. 0.64. What is the ratio of the Aid flow (current US$) of Yemen, Rep. in 1998 to that in 1999?
Offer a very short reply. 1.49. What is the ratio of the Aid flow (current US$) in Antigua and Barbuda in 1998 to that in 2000?
Make the answer very short. 8.42. What is the ratio of the Aid flow (current US$) of Macedonia in 1998 to that in 2000?
Provide a short and direct response. 1.34. What is the ratio of the Aid flow (current US$) of Morocco in 1998 to that in 2000?
Offer a very short reply. 0.38. What is the ratio of the Aid flow (current US$) in Yemen, Rep. in 1998 to that in 2000?
Offer a very short reply. 2.97. What is the ratio of the Aid flow (current US$) of Antigua and Barbuda in 1998 to that in 2001?
Provide a succinct answer. 1.06. What is the ratio of the Aid flow (current US$) in Macedonia in 1998 to that in 2001?
Offer a very short reply. 0.53. What is the ratio of the Aid flow (current US$) in Morocco in 1998 to that in 2001?
Make the answer very short. 0.39. What is the ratio of the Aid flow (current US$) of Yemen, Rep. in 1998 to that in 2001?
Provide a succinct answer. 12.73. What is the ratio of the Aid flow (current US$) of Antigua and Barbuda in 1998 to that in 2002?
Give a very brief answer. 0.46. What is the ratio of the Aid flow (current US$) of Macedonia in 1998 to that in 2002?
Provide a succinct answer. 2.79. What is the ratio of the Aid flow (current US$) in Morocco in 1998 to that in 2002?
Ensure brevity in your answer.  0.96. What is the ratio of the Aid flow (current US$) of Yemen, Rep. in 1998 to that in 2002?
Provide a short and direct response. 10.43. What is the ratio of the Aid flow (current US$) of Antigua and Barbuda in 1999 to that in 2000?
Ensure brevity in your answer.  14.83. What is the ratio of the Aid flow (current US$) in Macedonia in 1999 to that in 2000?
Provide a short and direct response. 3.27. What is the ratio of the Aid flow (current US$) in Morocco in 1999 to that in 2000?
Offer a very short reply. 0.6. What is the ratio of the Aid flow (current US$) in Yemen, Rep. in 1999 to that in 2000?
Give a very brief answer. 2. What is the ratio of the Aid flow (current US$) of Antigua and Barbuda in 1999 to that in 2001?
Keep it short and to the point. 1.87. What is the ratio of the Aid flow (current US$) of Macedonia in 1999 to that in 2001?
Your response must be concise. 1.28. What is the ratio of the Aid flow (current US$) of Morocco in 1999 to that in 2001?
Give a very brief answer. 0.61. What is the ratio of the Aid flow (current US$) of Yemen, Rep. in 1999 to that in 2001?
Make the answer very short. 8.54. What is the ratio of the Aid flow (current US$) of Antigua and Barbuda in 1999 to that in 2002?
Your answer should be compact. 0.81. What is the ratio of the Aid flow (current US$) in Macedonia in 1999 to that in 2002?
Make the answer very short. 6.78. What is the ratio of the Aid flow (current US$) of Morocco in 1999 to that in 2002?
Keep it short and to the point. 1.51. What is the ratio of the Aid flow (current US$) of Yemen, Rep. in 1999 to that in 2002?
Keep it short and to the point. 7. What is the ratio of the Aid flow (current US$) of Antigua and Barbuda in 2000 to that in 2001?
Give a very brief answer. 0.13. What is the ratio of the Aid flow (current US$) in Macedonia in 2000 to that in 2001?
Your response must be concise. 0.39. What is the ratio of the Aid flow (current US$) of Morocco in 2000 to that in 2001?
Offer a terse response. 1.02. What is the ratio of the Aid flow (current US$) of Yemen, Rep. in 2000 to that in 2001?
Provide a short and direct response. 4.28. What is the ratio of the Aid flow (current US$) of Antigua and Barbuda in 2000 to that in 2002?
Give a very brief answer. 0.05. What is the ratio of the Aid flow (current US$) of Macedonia in 2000 to that in 2002?
Give a very brief answer. 2.07. What is the ratio of the Aid flow (current US$) of Morocco in 2000 to that in 2002?
Make the answer very short. 2.53. What is the ratio of the Aid flow (current US$) in Yemen, Rep. in 2000 to that in 2002?
Ensure brevity in your answer.  3.51. What is the ratio of the Aid flow (current US$) in Antigua and Barbuda in 2001 to that in 2002?
Keep it short and to the point. 0.44. What is the ratio of the Aid flow (current US$) in Macedonia in 2001 to that in 2002?
Provide a short and direct response. 5.28. What is the ratio of the Aid flow (current US$) of Morocco in 2001 to that in 2002?
Offer a terse response. 2.49. What is the ratio of the Aid flow (current US$) in Yemen, Rep. in 2001 to that in 2002?
Your response must be concise. 0.82. What is the difference between the highest and the second highest Aid flow (current US$) of Antigua and Barbuda?
Your answer should be very brief. 1.63e+06. What is the difference between the highest and the second highest Aid flow (current US$) of Macedonia?
Give a very brief answer. 5.74e+06. What is the difference between the highest and the second highest Aid flow (current US$) in Morocco?
Provide a succinct answer. 1.66e+06. What is the difference between the highest and the second highest Aid flow (current US$) in Yemen, Rep.?
Offer a terse response. 2.05e+07. What is the difference between the highest and the lowest Aid flow (current US$) of Antigua and Barbuda?
Make the answer very short. 8.42e+06. What is the difference between the highest and the lowest Aid flow (current US$) of Macedonia?
Your response must be concise. 2.21e+07. What is the difference between the highest and the lowest Aid flow (current US$) in Morocco?
Your answer should be compact. 7.96e+07. What is the difference between the highest and the lowest Aid flow (current US$) in Yemen, Rep.?
Offer a very short reply. 5.75e+07. 